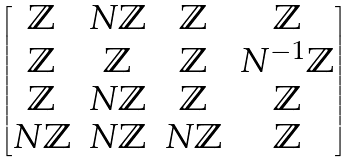Convert formula to latex. <formula><loc_0><loc_0><loc_500><loc_500>\begin{bmatrix} \mathbb { Z } & N \mathbb { Z } & \mathbb { Z } & \mathbb { Z } \\ \mathbb { Z } & \mathbb { Z } & \mathbb { Z } & N ^ { - 1 } \mathbb { Z } \\ \mathbb { Z } & N \mathbb { Z } & \mathbb { Z } & \mathbb { Z } \\ N \mathbb { Z } & N \mathbb { Z } & N \mathbb { Z } & \mathbb { Z } \end{bmatrix}</formula> 